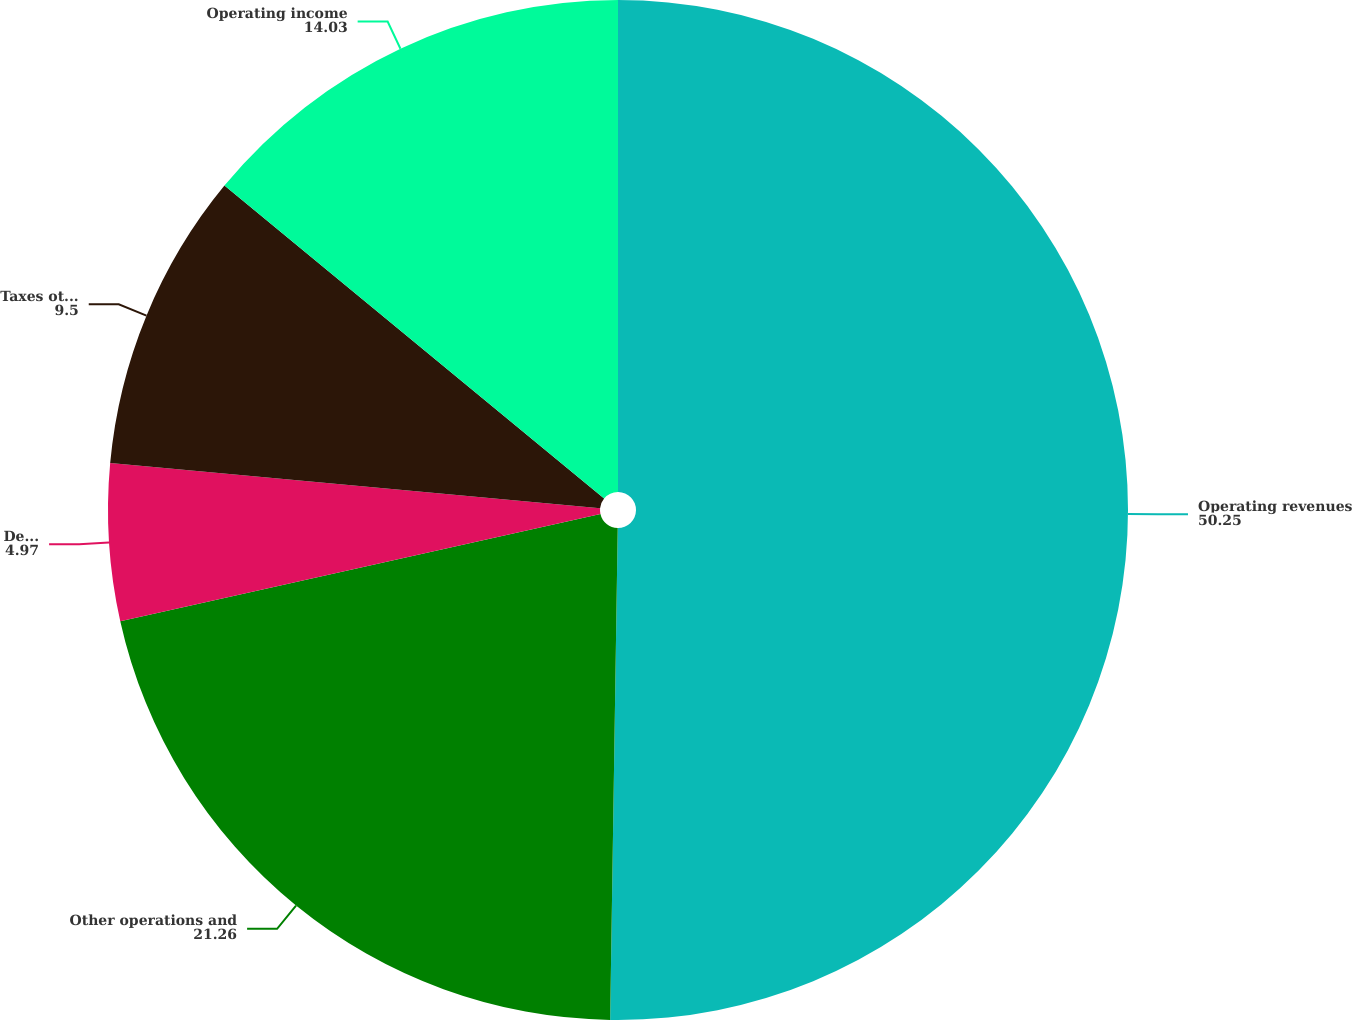Convert chart to OTSL. <chart><loc_0><loc_0><loc_500><loc_500><pie_chart><fcel>Operating revenues<fcel>Other operations and<fcel>Depreciation and amortization<fcel>Taxes other than income taxes<fcel>Operating income<nl><fcel>50.25%<fcel>21.26%<fcel>4.97%<fcel>9.5%<fcel>14.03%<nl></chart> 